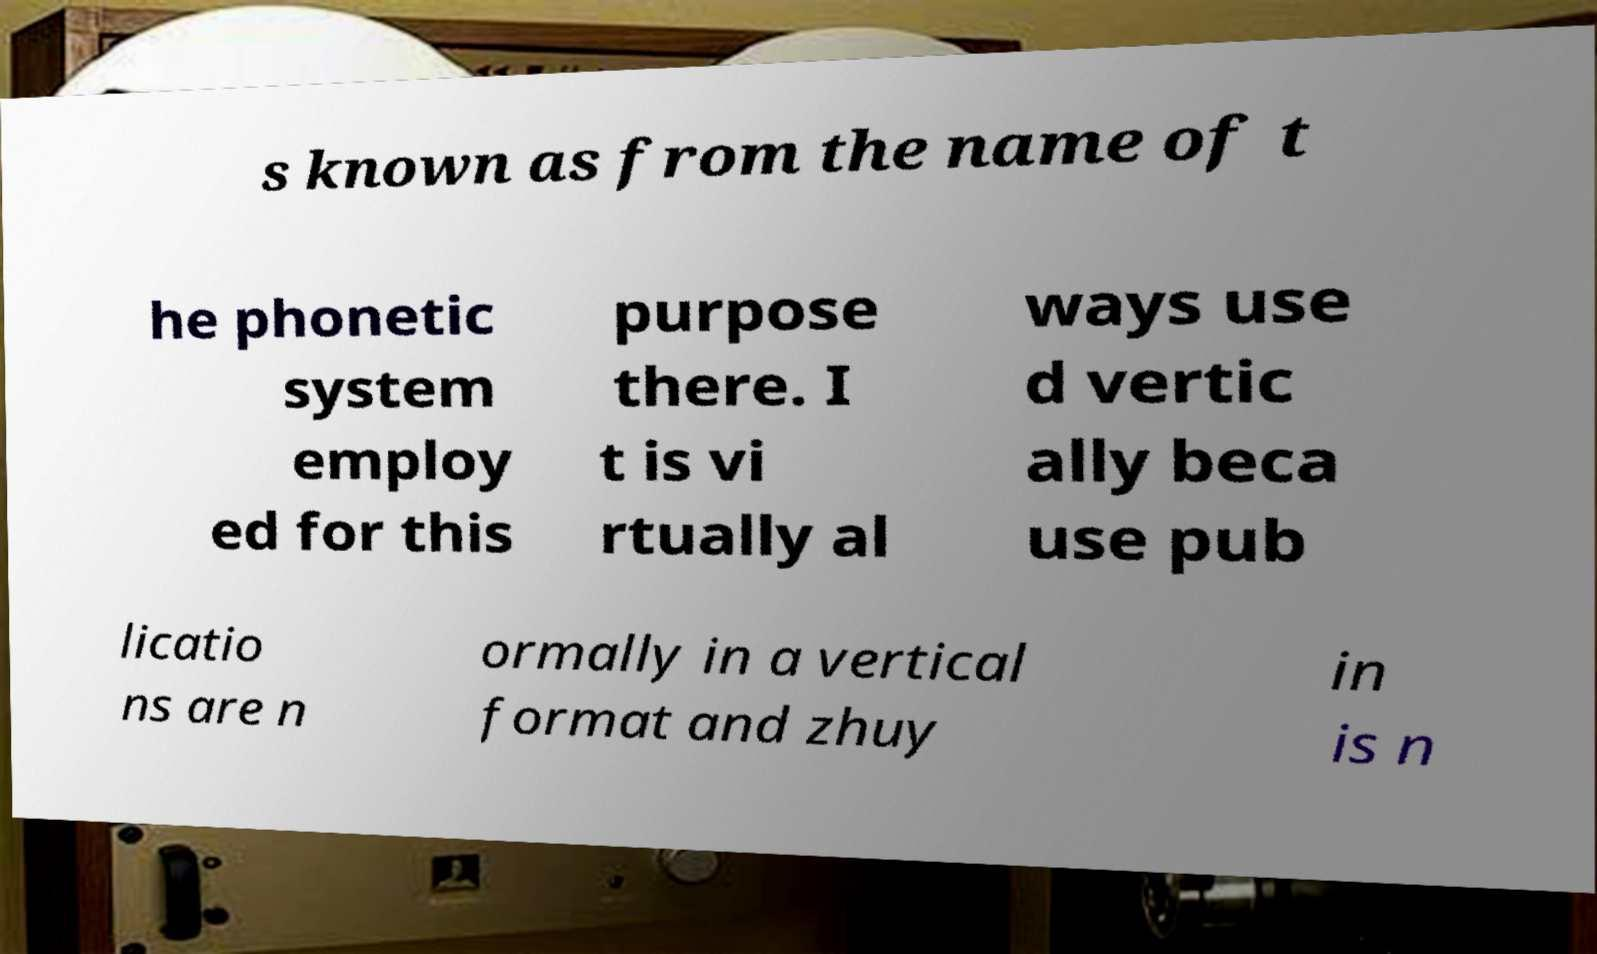There's text embedded in this image that I need extracted. Can you transcribe it verbatim? s known as from the name of t he phonetic system employ ed for this purpose there. I t is vi rtually al ways use d vertic ally beca use pub licatio ns are n ormally in a vertical format and zhuy in is n 